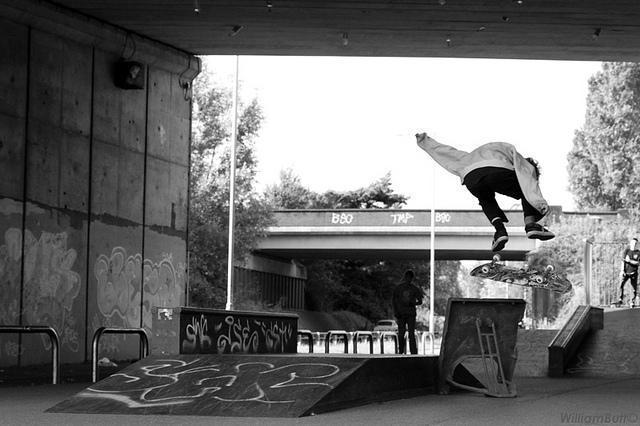How many people are there?
Give a very brief answer. 1. 